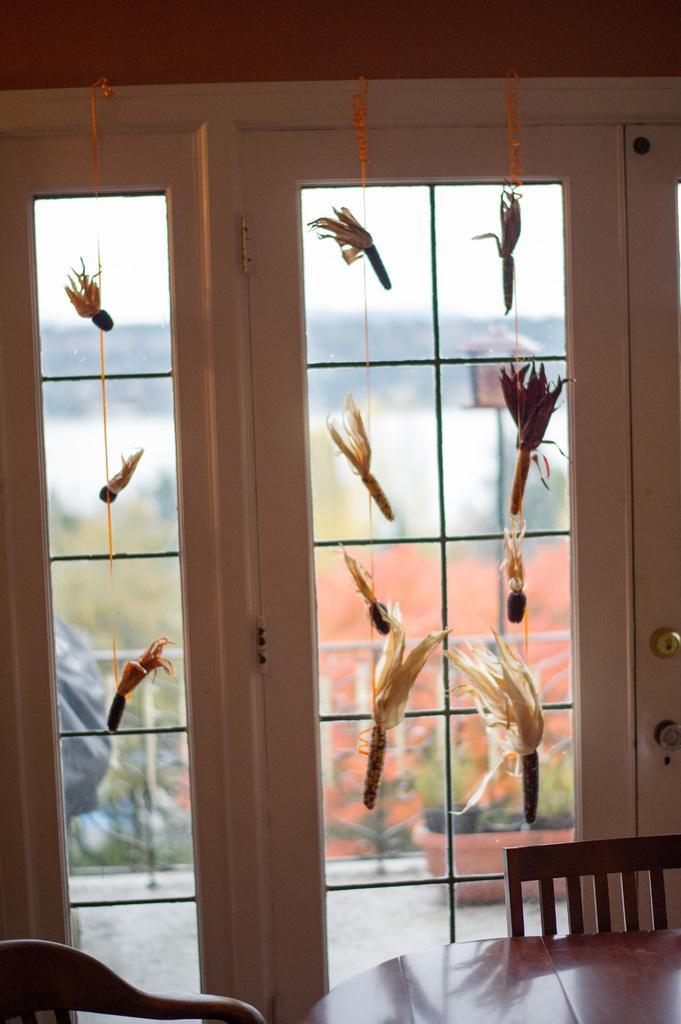How would you summarize this image in a sentence or two? This is an inside view. At the bottom there is a table and two chairs. In the middle of the image there is a window through which we can see the outside view. To the window there are few objects hanging which seems to be the leaves. 